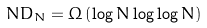<formula> <loc_0><loc_0><loc_500><loc_500>N D _ { N } = \Omega \left ( \log N \log \log N \right )</formula> 